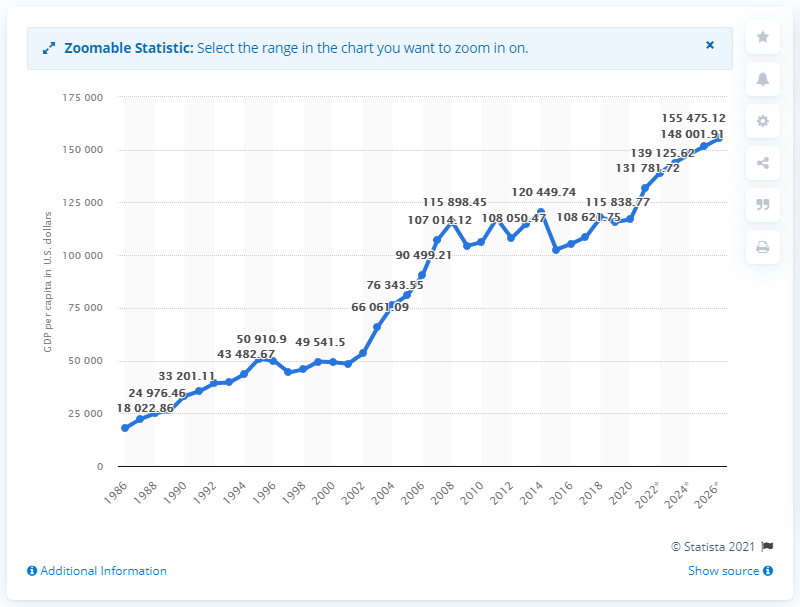Point out several critical features in this image. In 2015, Luxembourg had the highest GDP per capita among all countries in the world. 